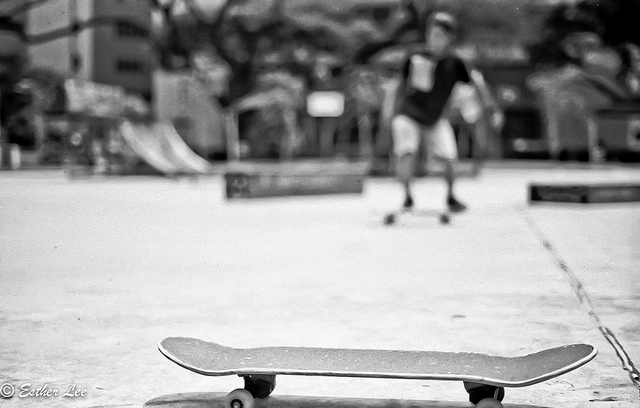Read all the text in this image. Lee Esther 